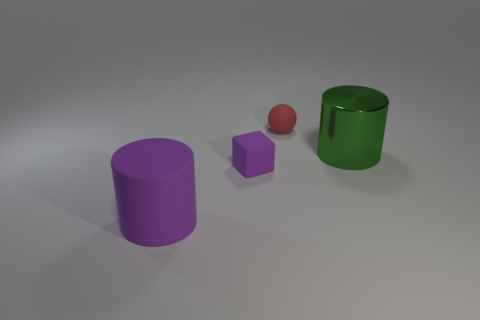Is there another tiny red matte thing of the same shape as the red thing?
Offer a very short reply. No. Is there a big green object that is to the right of the cylinder in front of the large green cylinder?
Offer a very short reply. Yes. What number of tiny gray balls have the same material as the small red ball?
Keep it short and to the point. 0. Is there a big cylinder?
Keep it short and to the point. Yes. What number of tiny cubes have the same color as the matte cylinder?
Keep it short and to the point. 1. Are the tiny cube and the big thing that is left of the red matte thing made of the same material?
Your response must be concise. Yes. Is the number of tiny purple matte cubes that are behind the red rubber thing greater than the number of cubes?
Your answer should be very brief. No. Is there any other thing that is the same size as the green metal object?
Offer a terse response. Yes. There is a rubber cube; does it have the same color as the large cylinder behind the block?
Ensure brevity in your answer.  No. Are there the same number of big green metal cylinders behind the big green object and metal cylinders that are to the right of the large purple matte thing?
Offer a very short reply. No. 